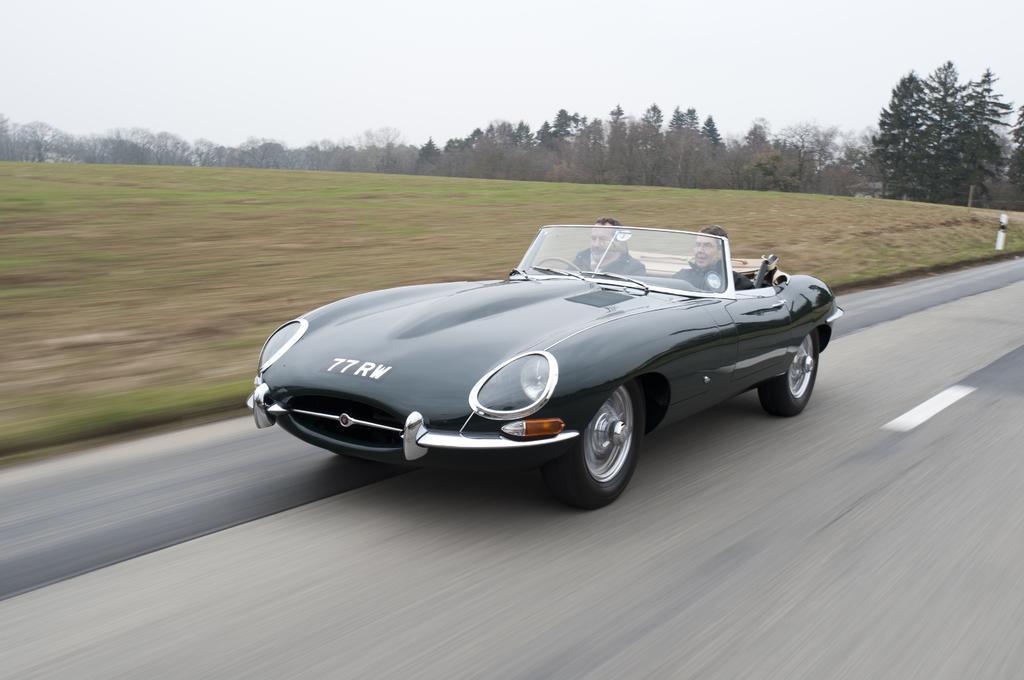How would you summarize this image in a sentence or two? This image is clicked outside. There are trees at the top. There is sky at the top. There is a car in the middle, it is in black color. There are two persons sitting in that car. 